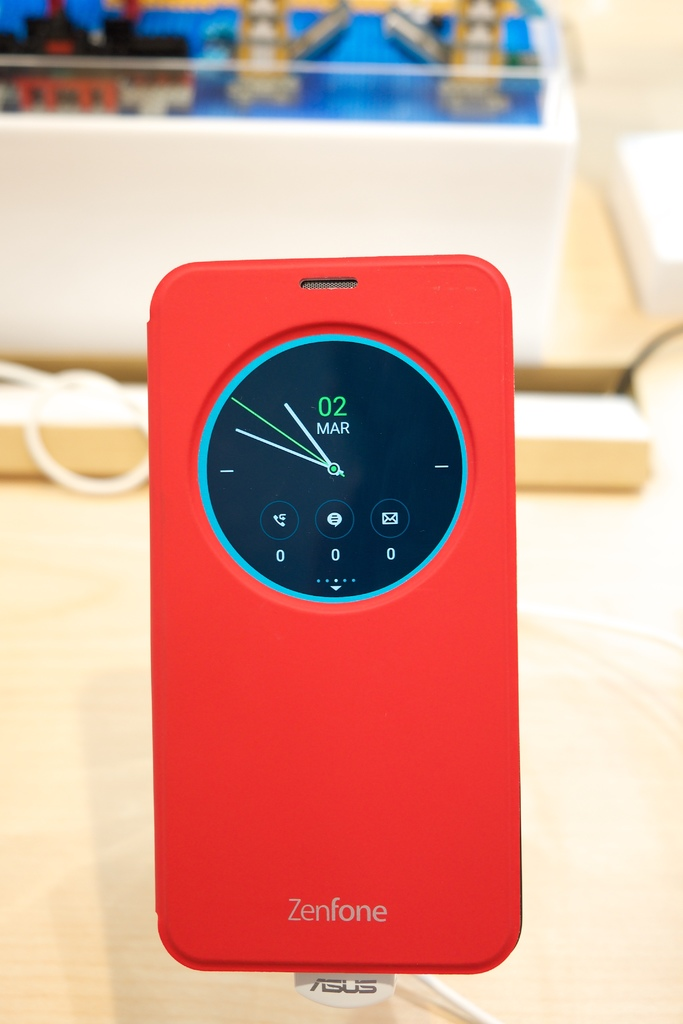Provide a one-sentence caption for the provided image.
Reference OCR token: Tm, CMMMO, 02, MAR, Zenfone, ASUS A red Zenfone case has clock on the back with the date March 2. 